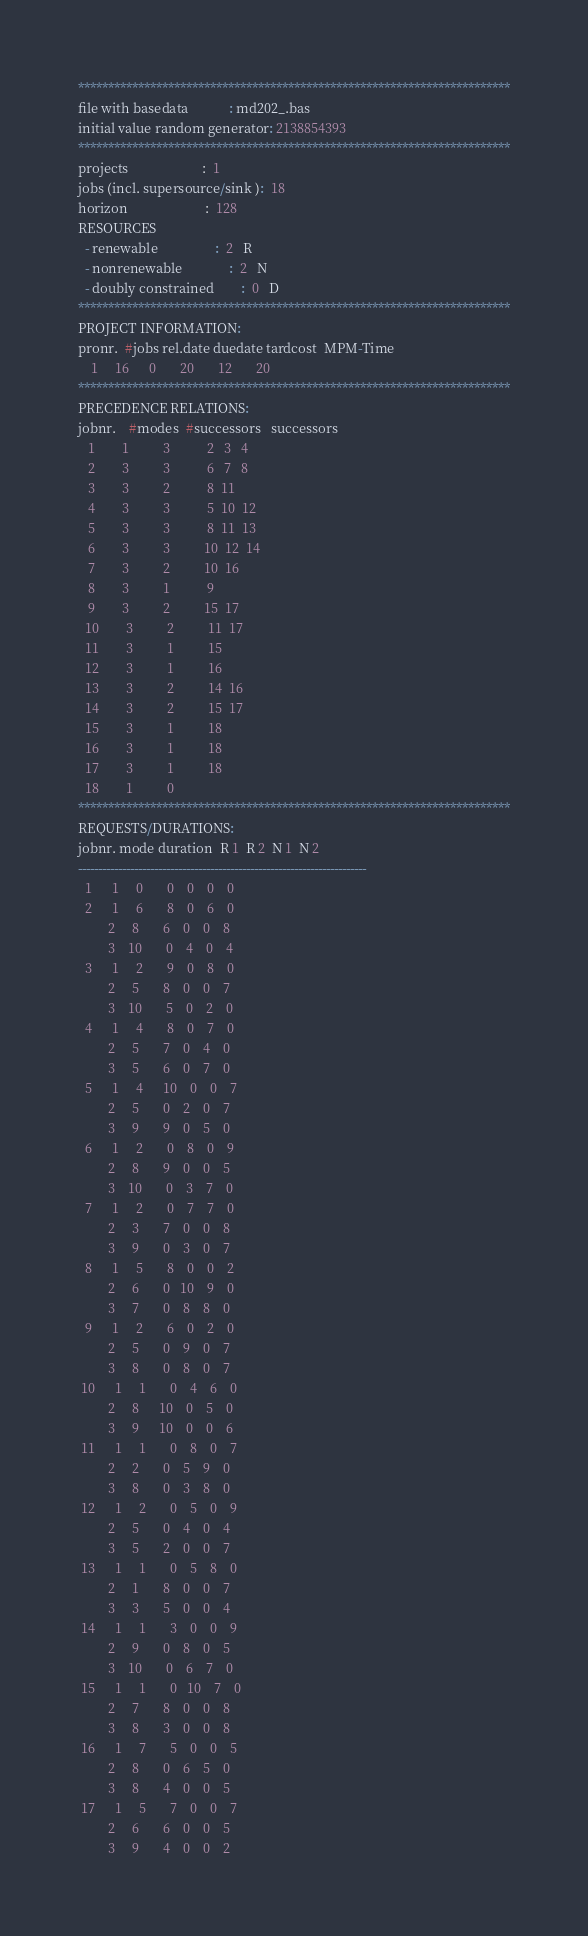<code> <loc_0><loc_0><loc_500><loc_500><_ObjectiveC_>************************************************************************
file with basedata            : md202_.bas
initial value random generator: 2138854393
************************************************************************
projects                      :  1
jobs (incl. supersource/sink ):  18
horizon                       :  128
RESOURCES
  - renewable                 :  2   R
  - nonrenewable              :  2   N
  - doubly constrained        :  0   D
************************************************************************
PROJECT INFORMATION:
pronr.  #jobs rel.date duedate tardcost  MPM-Time
    1     16      0       20       12       20
************************************************************************
PRECEDENCE RELATIONS:
jobnr.    #modes  #successors   successors
   1        1          3           2   3   4
   2        3          3           6   7   8
   3        3          2           8  11
   4        3          3           5  10  12
   5        3          3           8  11  13
   6        3          3          10  12  14
   7        3          2          10  16
   8        3          1           9
   9        3          2          15  17
  10        3          2          11  17
  11        3          1          15
  12        3          1          16
  13        3          2          14  16
  14        3          2          15  17
  15        3          1          18
  16        3          1          18
  17        3          1          18
  18        1          0        
************************************************************************
REQUESTS/DURATIONS:
jobnr. mode duration  R 1  R 2  N 1  N 2
------------------------------------------------------------------------
  1      1     0       0    0    0    0
  2      1     6       8    0    6    0
         2     8       6    0    0    8
         3    10       0    4    0    4
  3      1     2       9    0    8    0
         2     5       8    0    0    7
         3    10       5    0    2    0
  4      1     4       8    0    7    0
         2     5       7    0    4    0
         3     5       6    0    7    0
  5      1     4      10    0    0    7
         2     5       0    2    0    7
         3     9       9    0    5    0
  6      1     2       0    8    0    9
         2     8       9    0    0    5
         3    10       0    3    7    0
  7      1     2       0    7    7    0
         2     3       7    0    0    8
         3     9       0    3    0    7
  8      1     5       8    0    0    2
         2     6       0   10    9    0
         3     7       0    8    8    0
  9      1     2       6    0    2    0
         2     5       0    9    0    7
         3     8       0    8    0    7
 10      1     1       0    4    6    0
         2     8      10    0    5    0
         3     9      10    0    0    6
 11      1     1       0    8    0    7
         2     2       0    5    9    0
         3     8       0    3    8    0
 12      1     2       0    5    0    9
         2     5       0    4    0    4
         3     5       2    0    0    7
 13      1     1       0    5    8    0
         2     1       8    0    0    7
         3     3       5    0    0    4
 14      1     1       3    0    0    9
         2     9       0    8    0    5
         3    10       0    6    7    0
 15      1     1       0   10    7    0
         2     7       8    0    0    8
         3     8       3    0    0    8
 16      1     7       5    0    0    5
         2     8       0    6    5    0
         3     8       4    0    0    5
 17      1     5       7    0    0    7
         2     6       6    0    0    5
         3     9       4    0    0    2</code> 